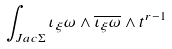Convert formula to latex. <formula><loc_0><loc_0><loc_500><loc_500>\int _ { J a c \Sigma } \iota _ { \xi } \omega \wedge \overline { { { \iota _ { \xi } \omega } } } \wedge t ^ { r - 1 }</formula> 